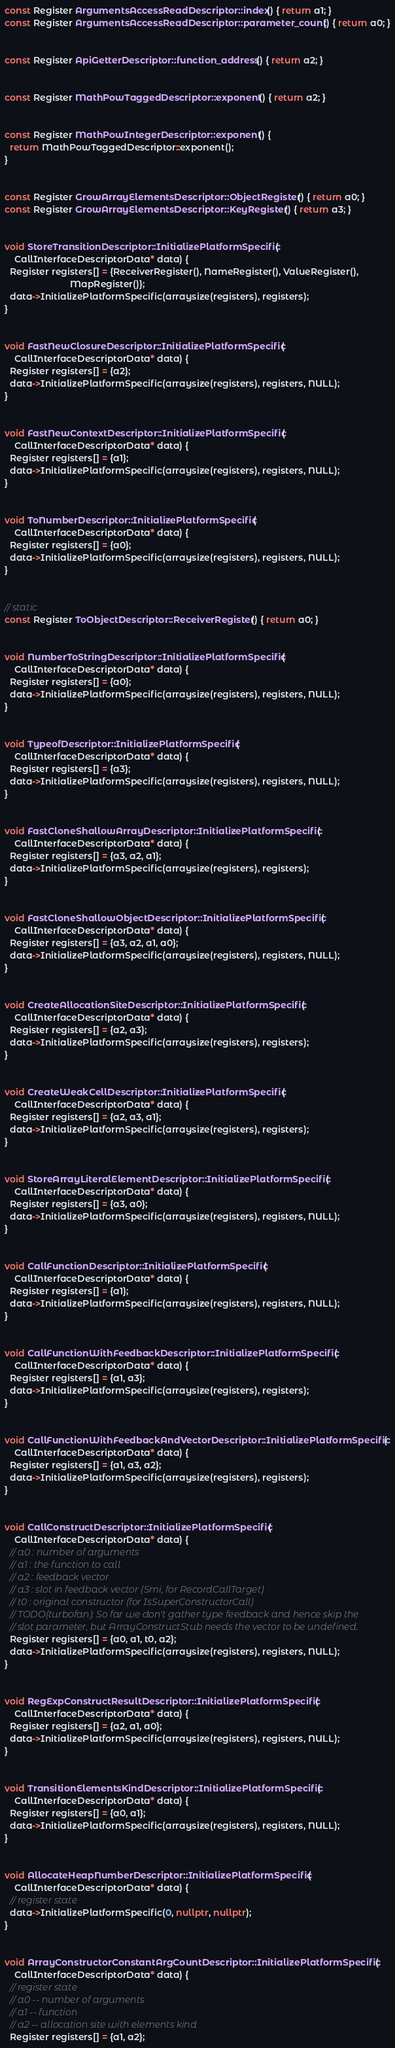<code> <loc_0><loc_0><loc_500><loc_500><_C++_>const Register ArgumentsAccessReadDescriptor::index() { return a1; }
const Register ArgumentsAccessReadDescriptor::parameter_count() { return a0; }


const Register ApiGetterDescriptor::function_address() { return a2; }


const Register MathPowTaggedDescriptor::exponent() { return a2; }


const Register MathPowIntegerDescriptor::exponent() {
  return MathPowTaggedDescriptor::exponent();
}


const Register GrowArrayElementsDescriptor::ObjectRegister() { return a0; }
const Register GrowArrayElementsDescriptor::KeyRegister() { return a3; }


void StoreTransitionDescriptor::InitializePlatformSpecific(
    CallInterfaceDescriptorData* data) {
  Register registers[] = {ReceiverRegister(), NameRegister(), ValueRegister(),
                          MapRegister()};
  data->InitializePlatformSpecific(arraysize(registers), registers);
}


void FastNewClosureDescriptor::InitializePlatformSpecific(
    CallInterfaceDescriptorData* data) {
  Register registers[] = {a2};
  data->InitializePlatformSpecific(arraysize(registers), registers, NULL);
}


void FastNewContextDescriptor::InitializePlatformSpecific(
    CallInterfaceDescriptorData* data) {
  Register registers[] = {a1};
  data->InitializePlatformSpecific(arraysize(registers), registers, NULL);
}


void ToNumberDescriptor::InitializePlatformSpecific(
    CallInterfaceDescriptorData* data) {
  Register registers[] = {a0};
  data->InitializePlatformSpecific(arraysize(registers), registers, NULL);
}


// static
const Register ToObjectDescriptor::ReceiverRegister() { return a0; }


void NumberToStringDescriptor::InitializePlatformSpecific(
    CallInterfaceDescriptorData* data) {
  Register registers[] = {a0};
  data->InitializePlatformSpecific(arraysize(registers), registers, NULL);
}


void TypeofDescriptor::InitializePlatformSpecific(
    CallInterfaceDescriptorData* data) {
  Register registers[] = {a3};
  data->InitializePlatformSpecific(arraysize(registers), registers, NULL);
}


void FastCloneShallowArrayDescriptor::InitializePlatformSpecific(
    CallInterfaceDescriptorData* data) {
  Register registers[] = {a3, a2, a1};
  data->InitializePlatformSpecific(arraysize(registers), registers);
}


void FastCloneShallowObjectDescriptor::InitializePlatformSpecific(
    CallInterfaceDescriptorData* data) {
  Register registers[] = {a3, a2, a1, a0};
  data->InitializePlatformSpecific(arraysize(registers), registers, NULL);
}


void CreateAllocationSiteDescriptor::InitializePlatformSpecific(
    CallInterfaceDescriptorData* data) {
  Register registers[] = {a2, a3};
  data->InitializePlatformSpecific(arraysize(registers), registers);
}


void CreateWeakCellDescriptor::InitializePlatformSpecific(
    CallInterfaceDescriptorData* data) {
  Register registers[] = {a2, a3, a1};
  data->InitializePlatformSpecific(arraysize(registers), registers);
}


void StoreArrayLiteralElementDescriptor::InitializePlatformSpecific(
    CallInterfaceDescriptorData* data) {
  Register registers[] = {a3, a0};
  data->InitializePlatformSpecific(arraysize(registers), registers, NULL);
}


void CallFunctionDescriptor::InitializePlatformSpecific(
    CallInterfaceDescriptorData* data) {
  Register registers[] = {a1};
  data->InitializePlatformSpecific(arraysize(registers), registers, NULL);
}


void CallFunctionWithFeedbackDescriptor::InitializePlatformSpecific(
    CallInterfaceDescriptorData* data) {
  Register registers[] = {a1, a3};
  data->InitializePlatformSpecific(arraysize(registers), registers);
}


void CallFunctionWithFeedbackAndVectorDescriptor::InitializePlatformSpecific(
    CallInterfaceDescriptorData* data) {
  Register registers[] = {a1, a3, a2};
  data->InitializePlatformSpecific(arraysize(registers), registers);
}


void CallConstructDescriptor::InitializePlatformSpecific(
    CallInterfaceDescriptorData* data) {
  // a0 : number of arguments
  // a1 : the function to call
  // a2 : feedback vector
  // a3 : slot in feedback vector (Smi, for RecordCallTarget)
  // t0 : original constructor (for IsSuperConstructorCall)
  // TODO(turbofan): So far we don't gather type feedback and hence skip the
  // slot parameter, but ArrayConstructStub needs the vector to be undefined.
  Register registers[] = {a0, a1, t0, a2};
  data->InitializePlatformSpecific(arraysize(registers), registers, NULL);
}


void RegExpConstructResultDescriptor::InitializePlatformSpecific(
    CallInterfaceDescriptorData* data) {
  Register registers[] = {a2, a1, a0};
  data->InitializePlatformSpecific(arraysize(registers), registers, NULL);
}


void TransitionElementsKindDescriptor::InitializePlatformSpecific(
    CallInterfaceDescriptorData* data) {
  Register registers[] = {a0, a1};
  data->InitializePlatformSpecific(arraysize(registers), registers, NULL);
}


void AllocateHeapNumberDescriptor::InitializePlatformSpecific(
    CallInterfaceDescriptorData* data) {
  // register state
  data->InitializePlatformSpecific(0, nullptr, nullptr);
}


void ArrayConstructorConstantArgCountDescriptor::InitializePlatformSpecific(
    CallInterfaceDescriptorData* data) {
  // register state
  // a0 -- number of arguments
  // a1 -- function
  // a2 -- allocation site with elements kind
  Register registers[] = {a1, a2};</code> 